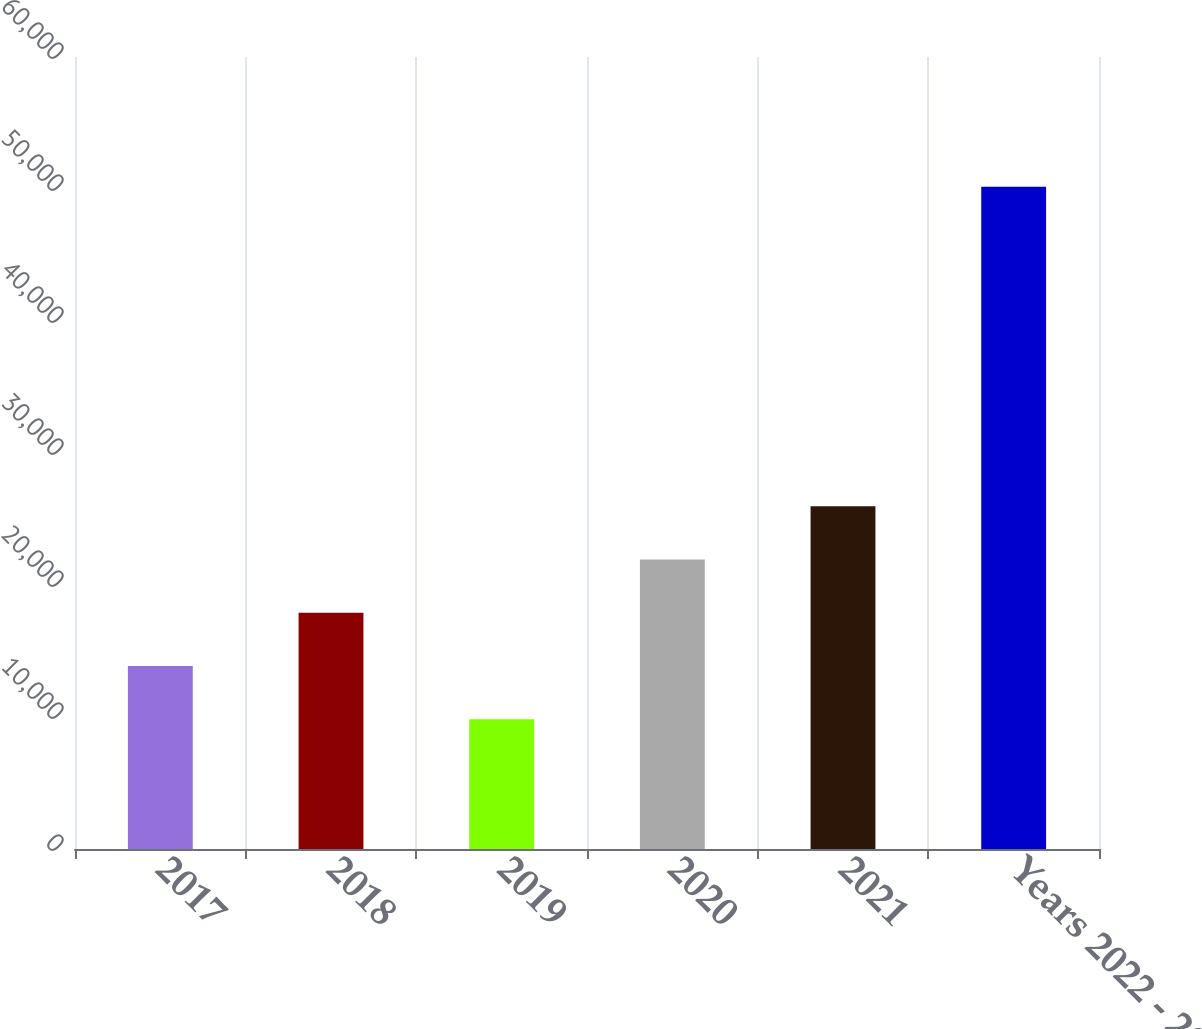<chart> <loc_0><loc_0><loc_500><loc_500><bar_chart><fcel>2017<fcel>2018<fcel>2019<fcel>2020<fcel>2021<fcel>Years 2022 - 2026<nl><fcel>13855.5<fcel>17890<fcel>9821<fcel>21924.5<fcel>25959<fcel>50166<nl></chart> 